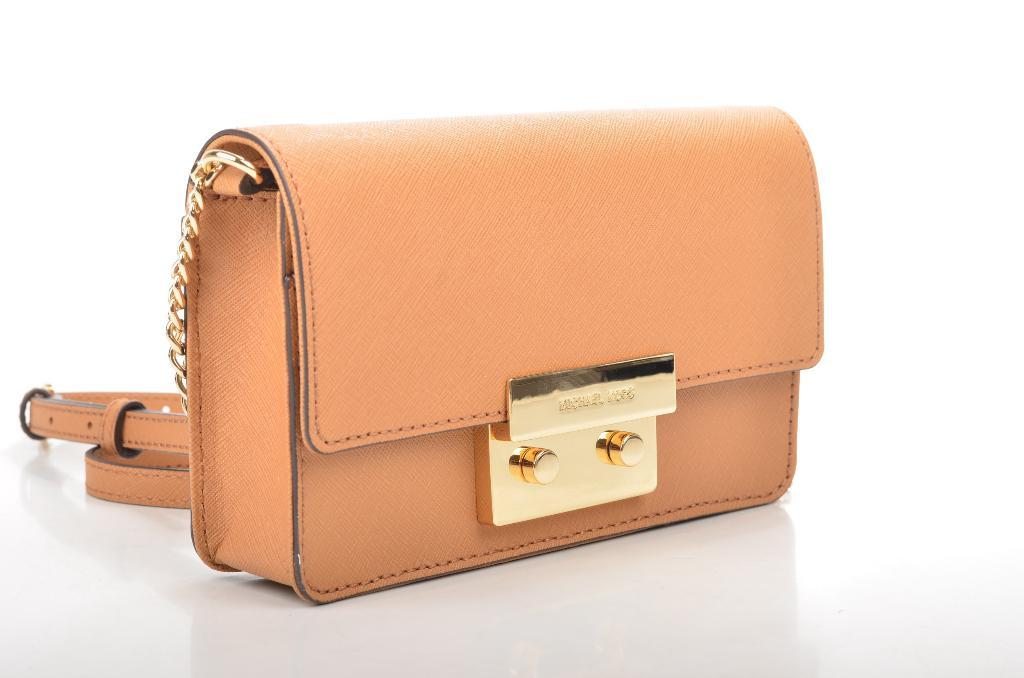What material is the bag made of in the image? The bag is made of leather. What color is the bag in the image? The bag is orange in color. What type of accessory is attached to the bag? There is a gold color clip attached to the bag. Is there any additional leather feature on the bag? Yes, there is a leather hanging attached to the bag. What type of pen is visible in the image? There is no pen present in the image. What kind of game is being played in the image? There is no game being played in the image. 